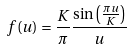<formula> <loc_0><loc_0><loc_500><loc_500>f ( u ) = \frac { K } { \pi } \frac { \sin \left ( \frac { \pi u } { K } \right ) } { u }</formula> 